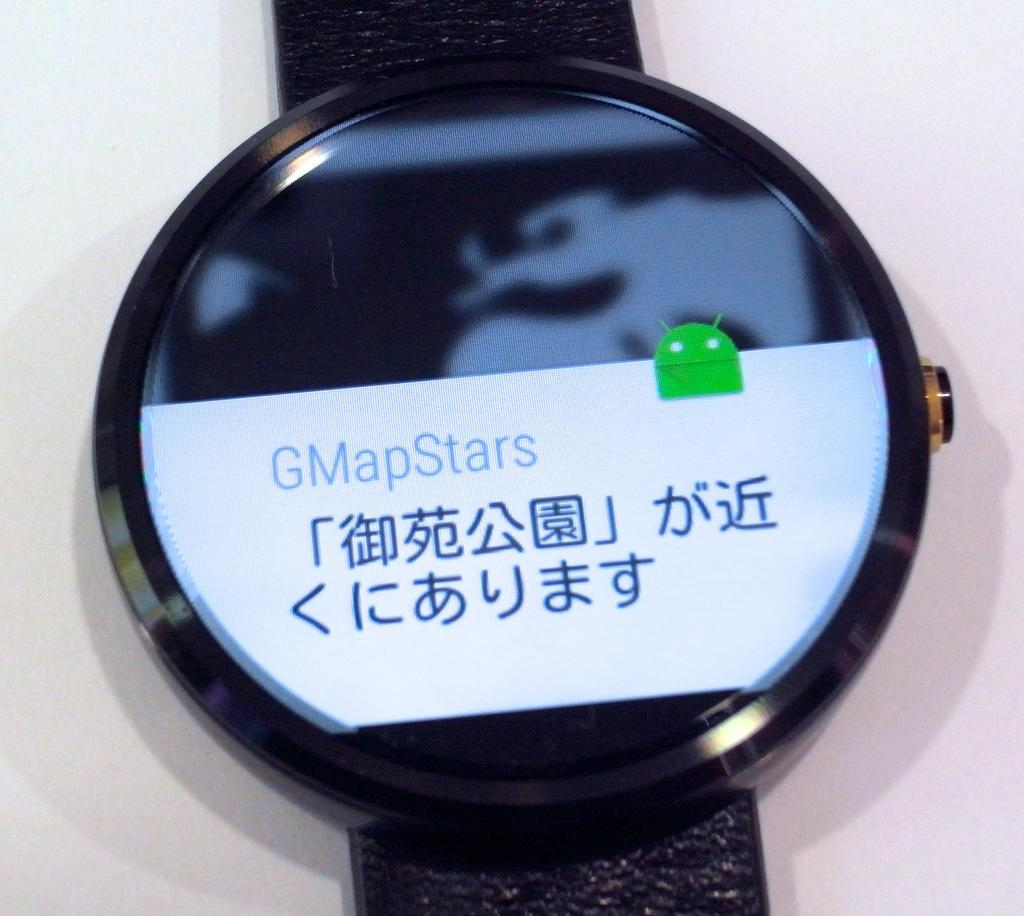What object is the main focus of the image? There is a watch in the image. What is the color of the surface the watch is placed on? The watch is on a white surface. Can you read any text in the image? Yes, there is text visible in the image. How many people are sitting on the seat in the image? There is no seat present in the image, so it is not possible to answer that question. 